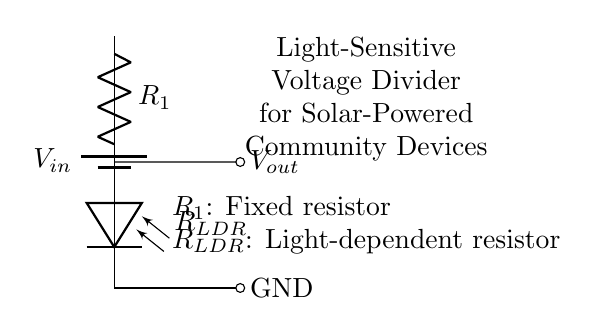What is the input voltage of this circuit? The input voltage, denoted as \( V_{in} \), is the voltage provided by the battery, but the specific value is not labeled on the diagram. It could be assumed to be a common value used in such circuits, typically 5V or 12V for small devices.
Answer: \( V_{in} \) (value not specified) What is the purpose of the light-dependent resistor? The light-dependent resistor, denoted as \( R_{LDR} \), changes its resistance based on the light intensity. In bright light, it has low resistance, allowing more current to pass, while in darkness, it has high resistance, reducing current. This regulates the output voltage based on surrounding light conditions.
Answer: To sense light levels What are the two components in the voltage divider? The voltage divider in this circuit consists of a fixed resistor \( R_1 \) and a light-dependent resistor \( R_{LDR} \). Together, these two resistors divide the input voltage into a lower output voltage \( V_{out} \), based on their resistance values.
Answer: \( R_1 \) and \( R_{LDR} \) How does the output voltage depend on light intensity? The output voltage \( V_{out} \) is determined by the ratio of the resistances of \( R_1 \) and \( R_{LDR} \). As light intensity increases, \( R_{LDR} \) decreases, which leads to a higher \( V_{out} \). Conversely, less light means \( R_{LDR} \) increases, reducing \( V_{out} \). Thus, there is an inverse relationship between light intensity and the output voltage.
Answer: Inversely proportional What happens if there is no light? If there is no light, the light-dependent resistor \( R_{LDR} \) will have a high resistance value, meaning very little current will flow through the circuit. This results in a significantly lower output voltage \( V_{out} \) which could potentially drop close to zero, depending on the value of \( R_1 \).
Answer: \( V_{out} \approx 0 \) How can this circuit be utilized in community solar-powered devices? This circuit can be used to automatically control solar-powered devices by adjusting their operation based on ambient light. When it is bright, the output voltage could trigger a device to turn on (like lights or fans), while at low light levels, the output could keep the device off to conserve energy.
Answer: For automated operation 